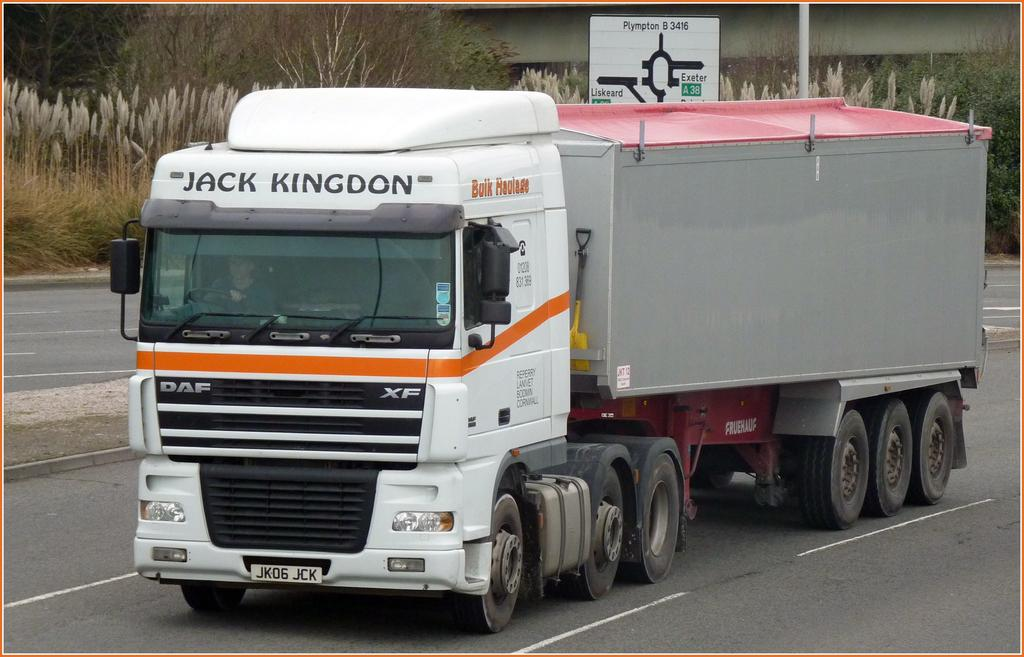What type of vehicle is on the road in the image? There is a truck on the road in the image. What is located at the back of the image? There is a sign board in the back of the image. What natural elements can be seen in the image? Trees and plants are visible in the image. Where is the drawer located in the image? There is no drawer present in the image. What type of sheet is covering the truck in the image? There is no sheet covering the truck in the image. 